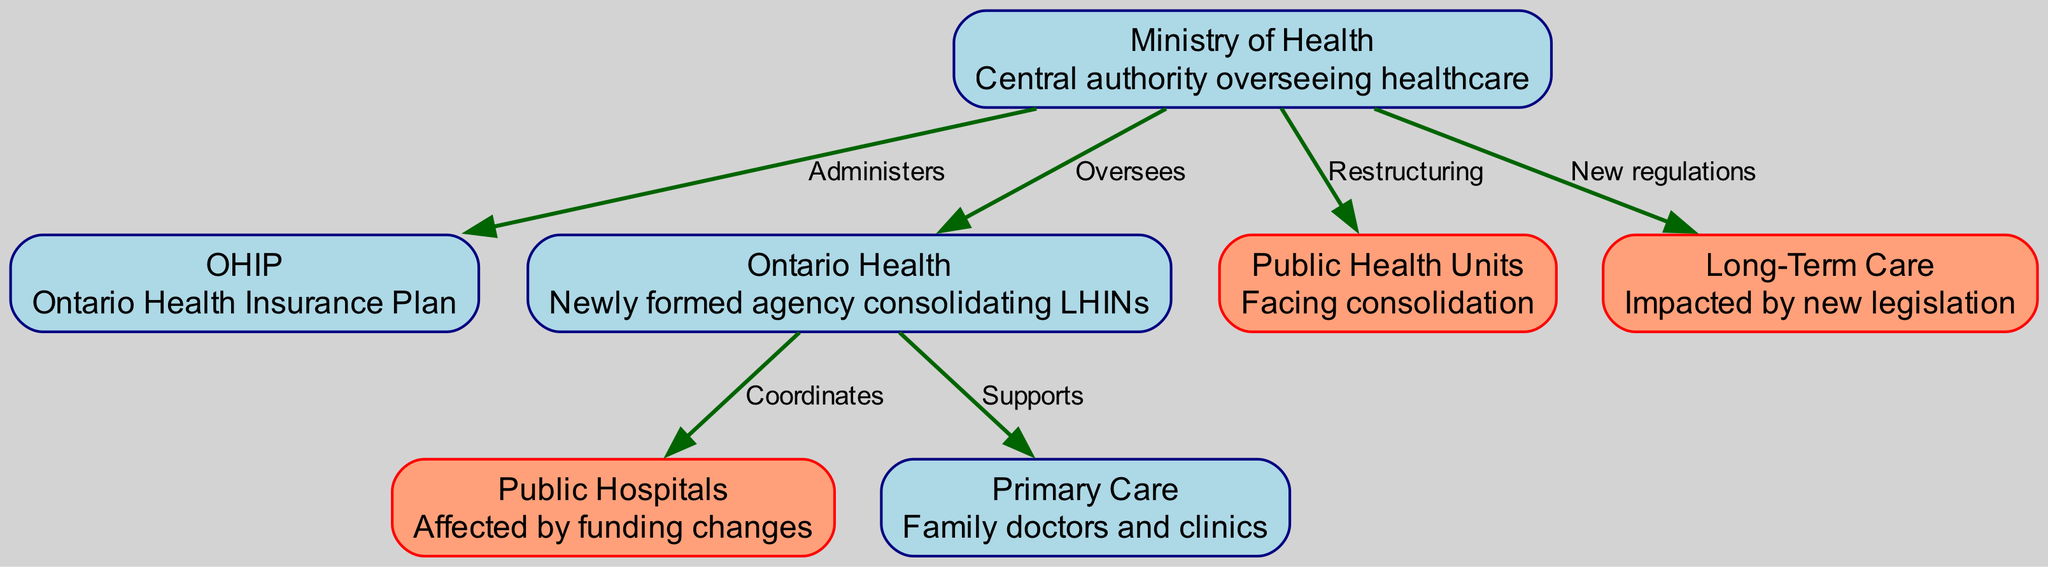What is the central authority overseeing healthcare? The diagram indicates that the "Ministry of Health" is the node labeled as the central authority overseeing healthcare.
Answer: Ministry of Health How many areas are affected by recent policy changes? The diagram shows that three specific areas are highlighted: Public Hospitals, Public Health Units, and Long-Term Care. Therefore, there are three areas affected by recent policy changes.
Answer: 3 Which node administers the Ontario Health Insurance Plan? The diagram shows a directed edge from the "Ministry of Health" node to the "OHIP" node, indicating that the Ministry administers OHIP.
Answer: Ministry of Health What type of healthcare unit faces consolidation? The diagram identifies "Public Health Units" as one of the nodes facing consolidation, with a corresponding edge showing restructuring by the Ministry.
Answer: Public Health Units Which entities does the "Ontario Health" agency coordinate? The diagram shows directed edges from the "Ontario Health" node to "Public Hospitals" and "Primary Care," meaning it coordinates these two entities.
Answer: Public Hospitals, Primary Care What new regulations impact long-term care? The diagram indicates that the "Ministry of Health" has introduced new regulations that specifically affect the "Long-Term Care" area, indicating a direct relationship.
Answer: New regulations Which nodes are highlighted in salmon color? The nodes that are highlighted in salmon color are "Public Hospitals," "Public Health Units," and "Long-Term Care," indicating that they are affected by recent policy changes.
Answer: Public Hospitals, Public Health Units, Long-Term Care What is the primary role of the Ministry of Health related to public health? According to the diagram, the "Ministry of Health" is involved in the restructuring of "Public Health Units," indicating its role in overseeing changes within this area.
Answer: Restructuring How does "Ontario Health" support primary care providers? The diagram indicates that "Ontario Health" has a directed edge labeled "Supports" leading to the "Primary Care" node, signifying its supportive role for primary care providers.
Answer: Supports 